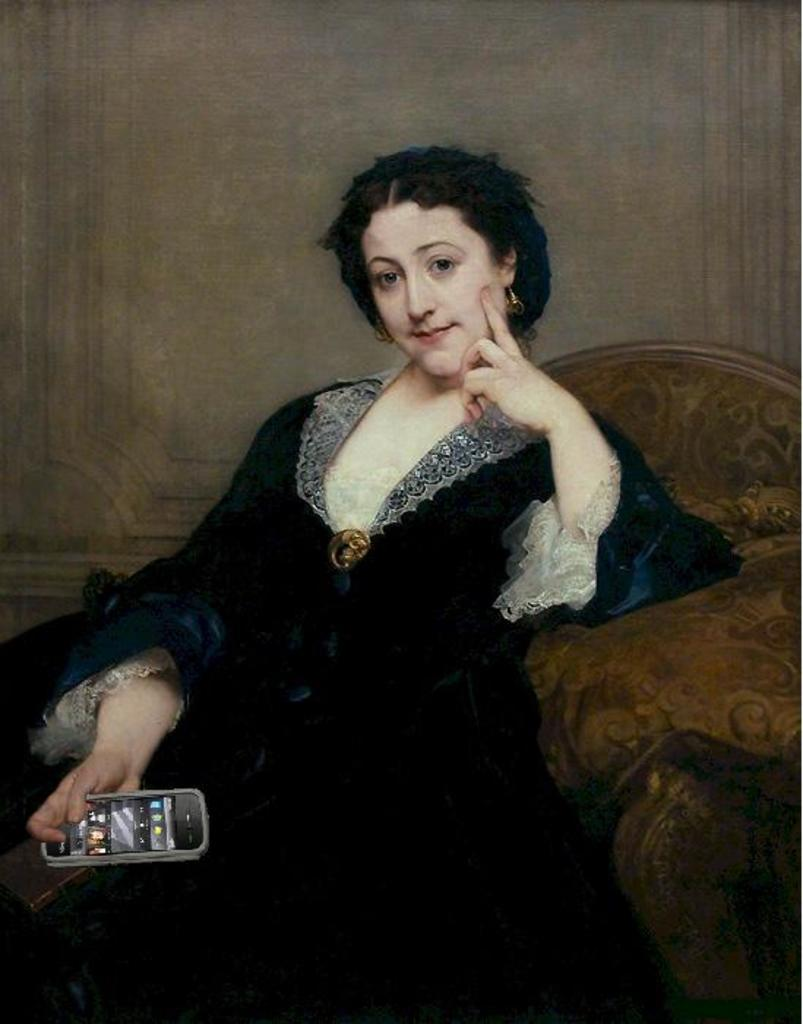Who is the main subject in the image? There is a woman in the image. What is the woman wearing? The woman is wearing a black dress. What is the woman doing in the image? The woman is sitting on a sofa. What object is the woman holding in her hand? The woman is holding a mobile phone in her hand. What is the woman's manager doing in the image? There is no mention of a manager in the image, so we cannot answer this question. 